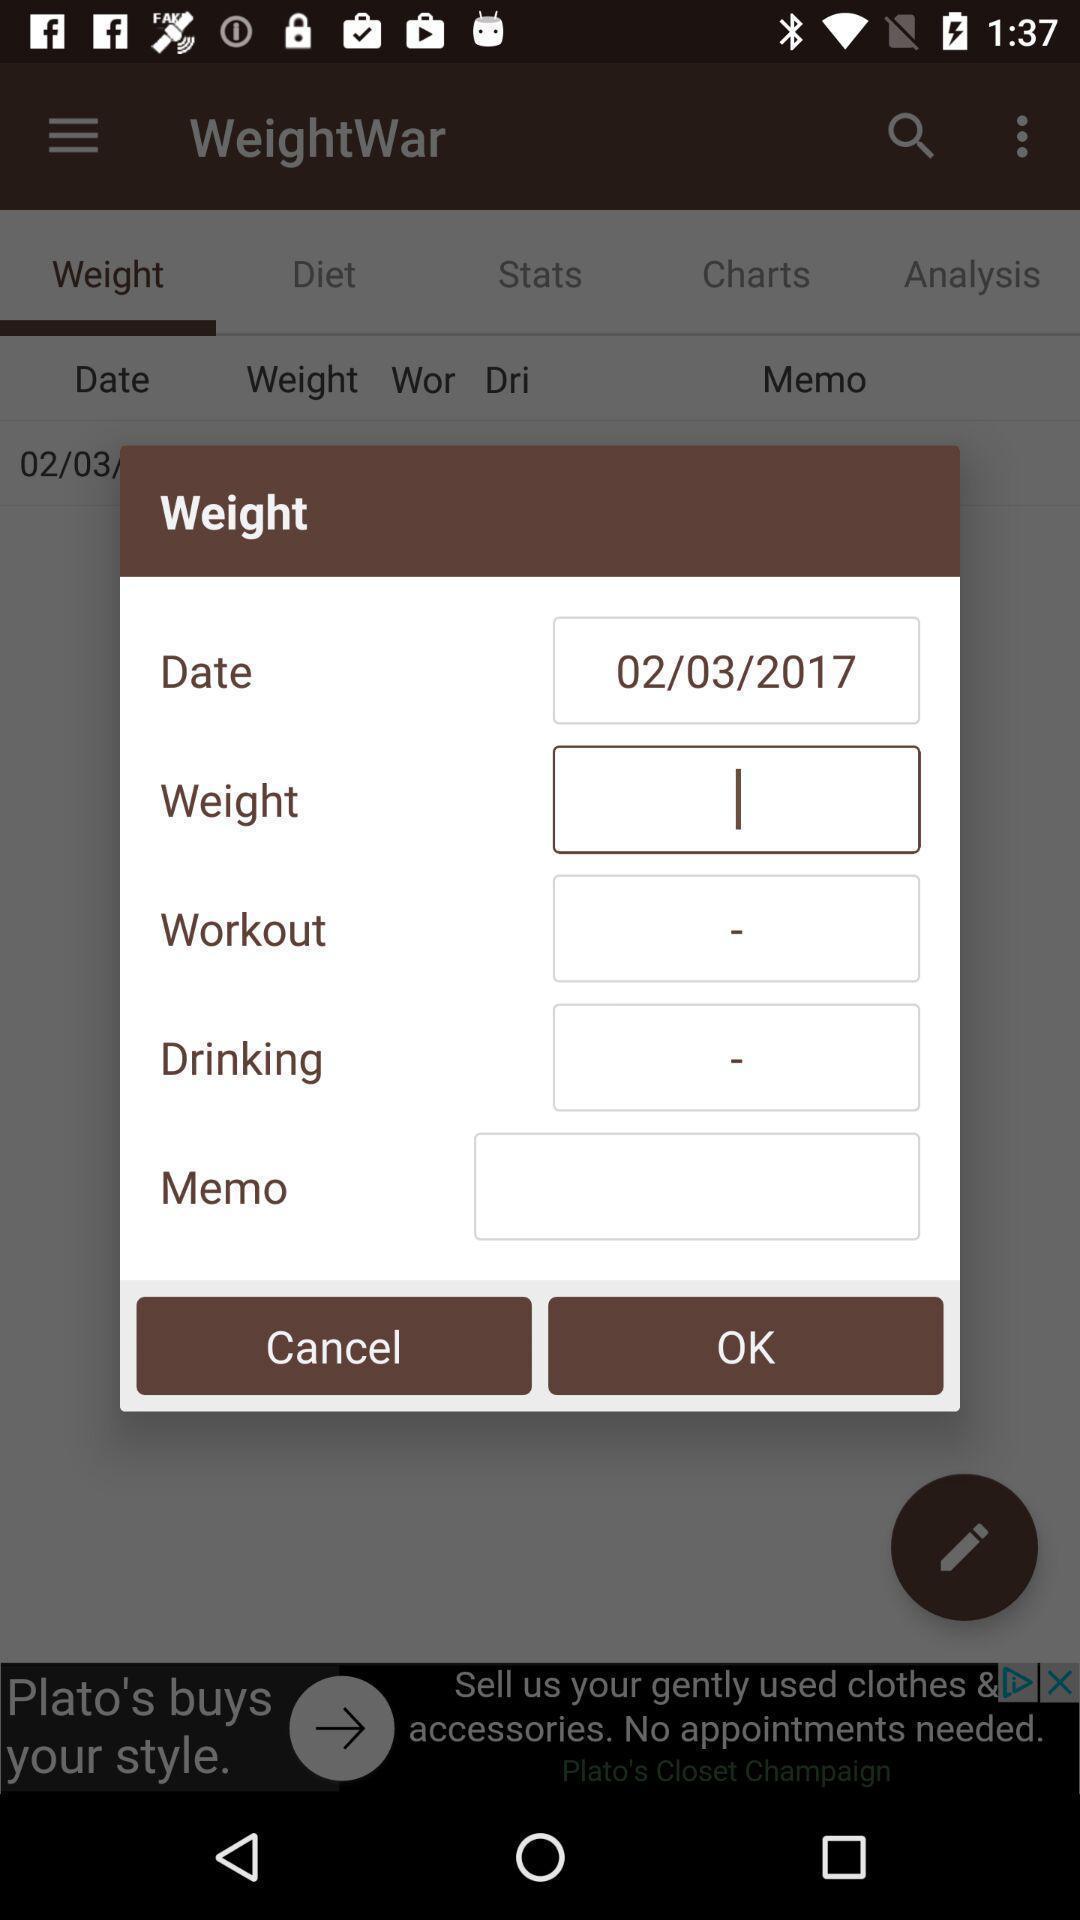Provide a textual representation of this image. Pop-up showing the result of weight in an health application. 